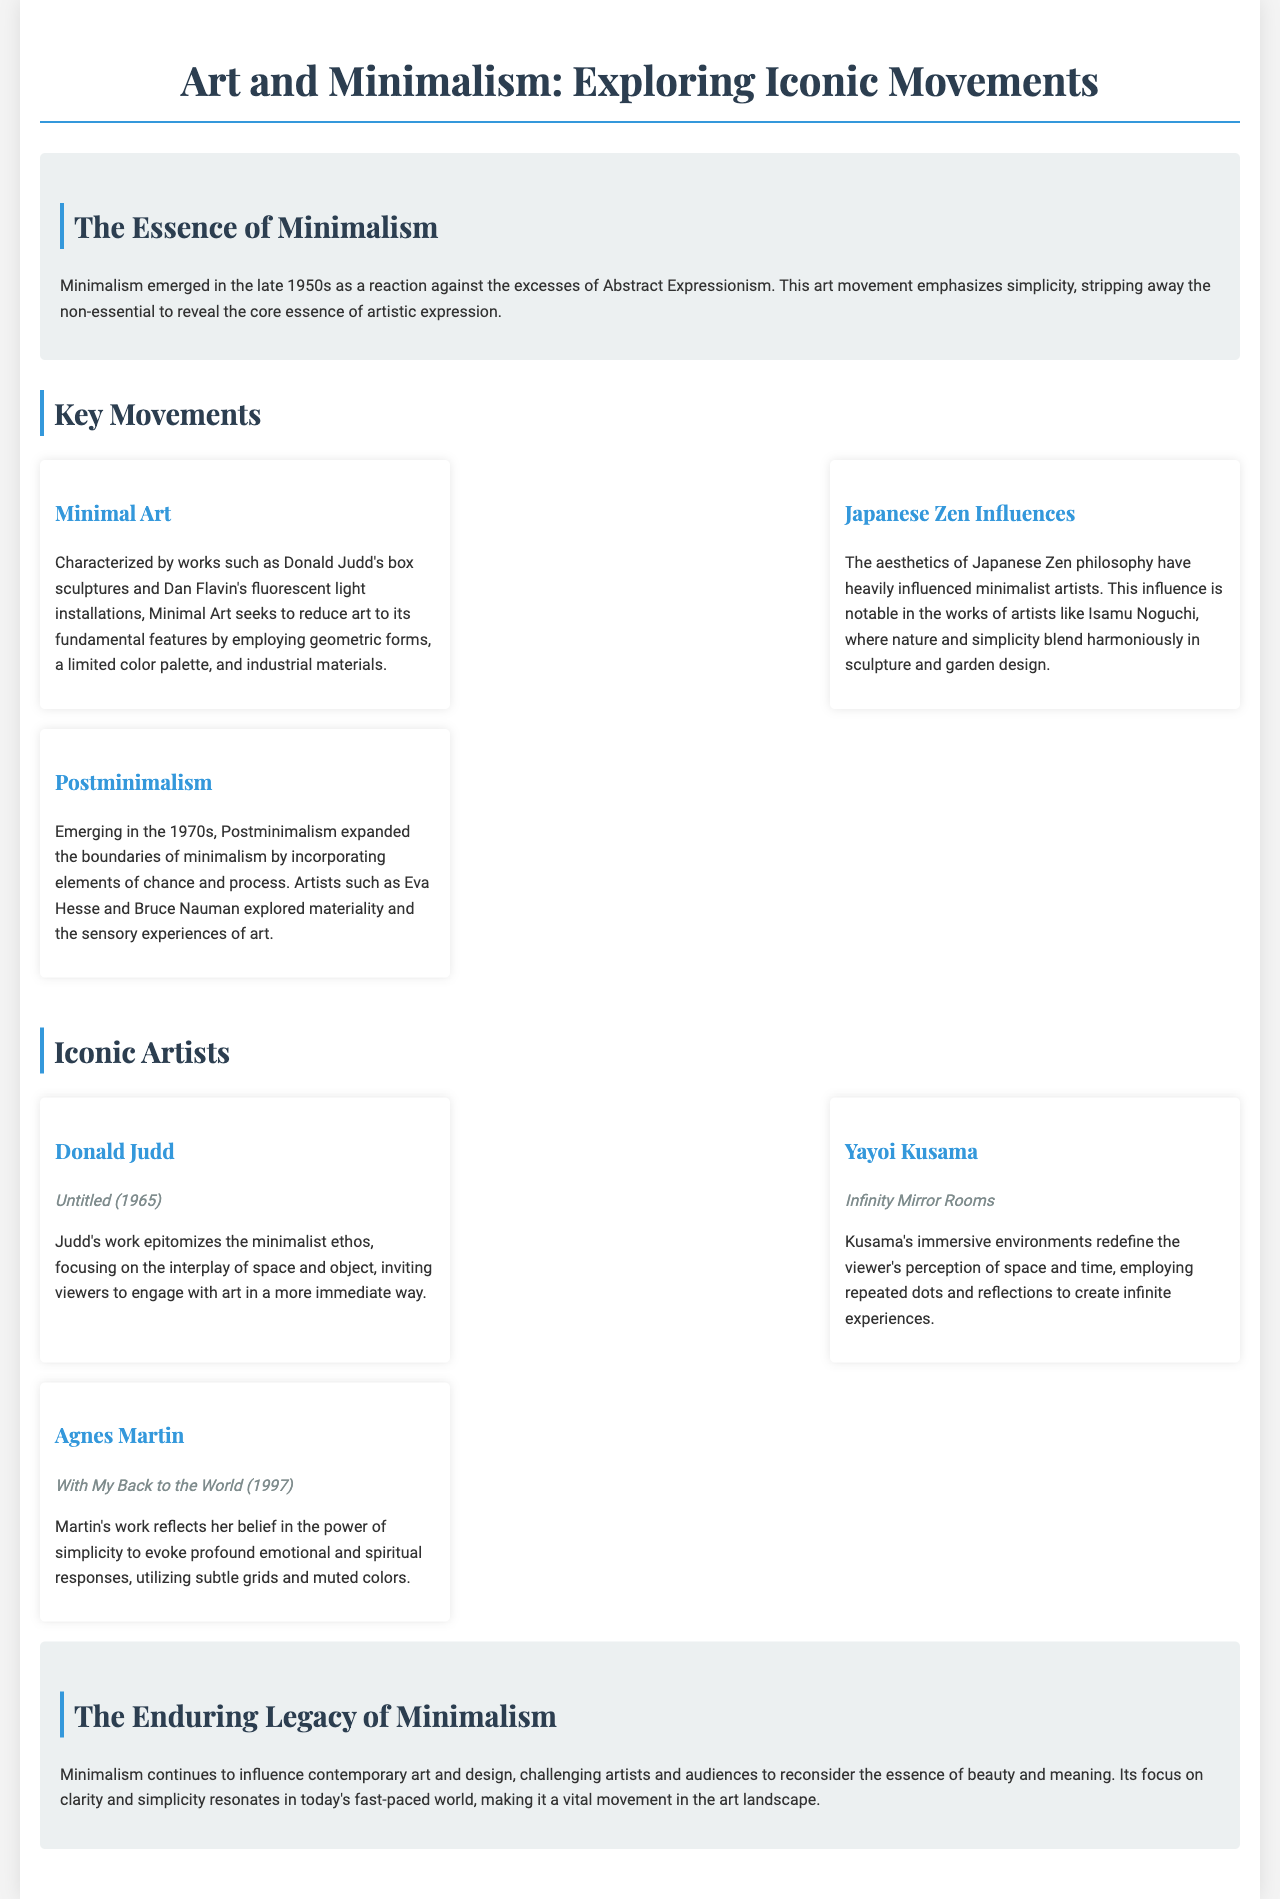what year did Minimalism emerge? The document states that Minimalism emerged in the late 1950s.
Answer: late 1950s who is associated with the work "Untitled (1965)"? The document lists Donald Judd as the artist of "Untitled (1965)."
Answer: Donald Judd what is the focus of Minimal Art? The document describes Minimal Art as seeking to reduce art to its fundamental features using geometric forms.
Answer: geometric forms which artist created the "Infinity Mirror Rooms"? Yayoi Kusama is identified in the document as the creator of the "Infinity Mirror Rooms."
Answer: Yayoi Kusama what does Postminimalism incorporate? The document notes that Postminimalism incorporated elements of chance and process.
Answer: chance and process what philosophy greatly influenced minimalist artists? The aesthetics of Japanese Zen philosophy is mentioned as a significant influence.
Answer: Japanese Zen philosophy who explores materiality and sensory experiences in their work? The document references artists such as Eva Hesse and Bruce Nauman in relation to materiality and sensory experiences.
Answer: Eva Hesse and Bruce Nauman what is a characteristic of Agnes Martin's artwork? The document mentions that Martin's work utilizes subtle grids and muted colors.
Answer: subtle grids and muted colors how does Minimalism resonate in today's world? The document states that Minimalism’s focus on clarity and simplicity resonates in today's fast-paced world.
Answer: clarity and simplicity 